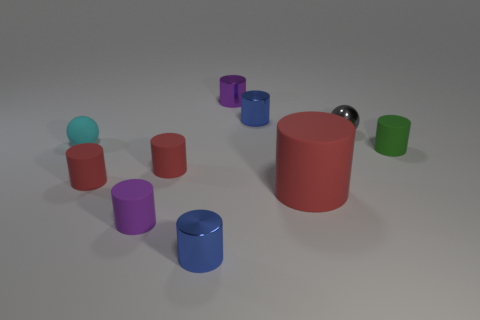How many large red things have the same shape as the tiny cyan thing?
Give a very brief answer. 0. Does the small object right of the small gray sphere have the same color as the shiny cylinder that is in front of the gray sphere?
Make the answer very short. No. What number of things are either small metallic blocks or cyan spheres?
Give a very brief answer. 1. What number of small blue objects are the same material as the large cylinder?
Give a very brief answer. 0. Is the number of tiny purple matte objects less than the number of small yellow shiny cylinders?
Provide a short and direct response. No. Are the purple thing in front of the tiny matte sphere and the tiny cyan object made of the same material?
Your response must be concise. Yes. How many cylinders are gray metal things or cyan things?
Ensure brevity in your answer.  0. There is a small object that is both in front of the cyan matte ball and on the right side of the large thing; what shape is it?
Your response must be concise. Cylinder. What is the color of the tiny matte cylinder in front of the tiny red matte cylinder left of the purple thing in front of the green rubber object?
Ensure brevity in your answer.  Purple. Is the number of objects left of the large cylinder less than the number of metal spheres?
Your response must be concise. No. 